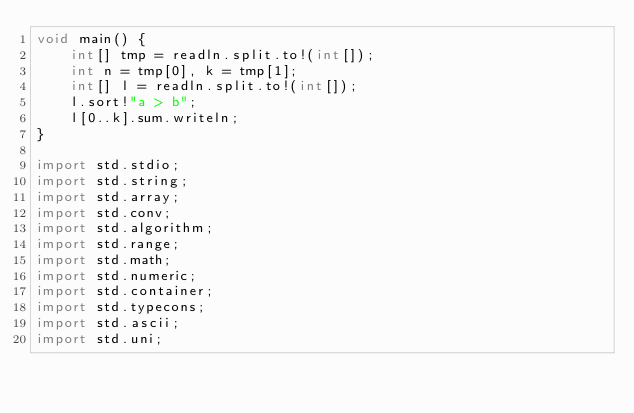<code> <loc_0><loc_0><loc_500><loc_500><_D_>void main() {
    int[] tmp = readln.split.to!(int[]);
    int n = tmp[0], k = tmp[1];
    int[] l = readln.split.to!(int[]);
    l.sort!"a > b";
    l[0..k].sum.writeln;
}

import std.stdio;
import std.string;
import std.array;
import std.conv;
import std.algorithm;
import std.range;
import std.math;
import std.numeric;
import std.container;
import std.typecons;
import std.ascii;
import std.uni;</code> 